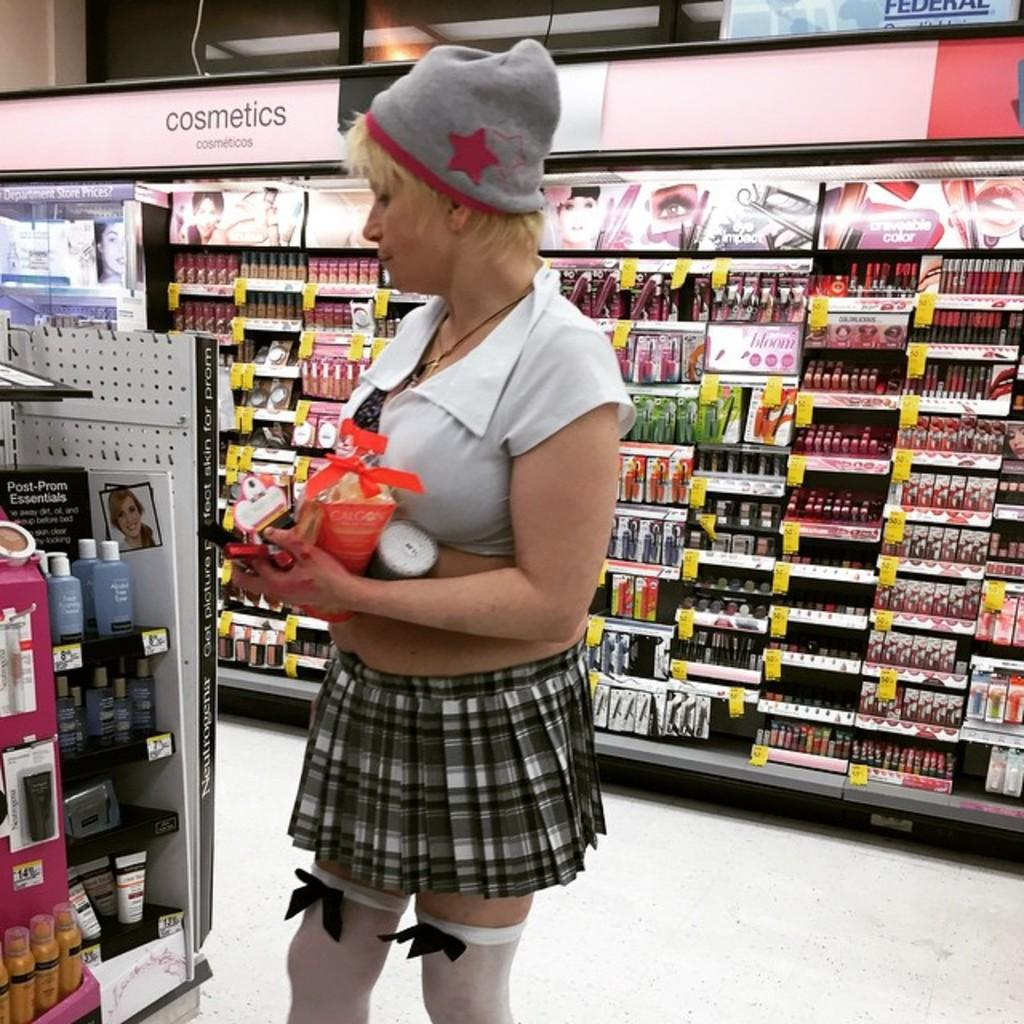<image>
Describe the image concisely. a girl in the cosmetic section of a drug store 